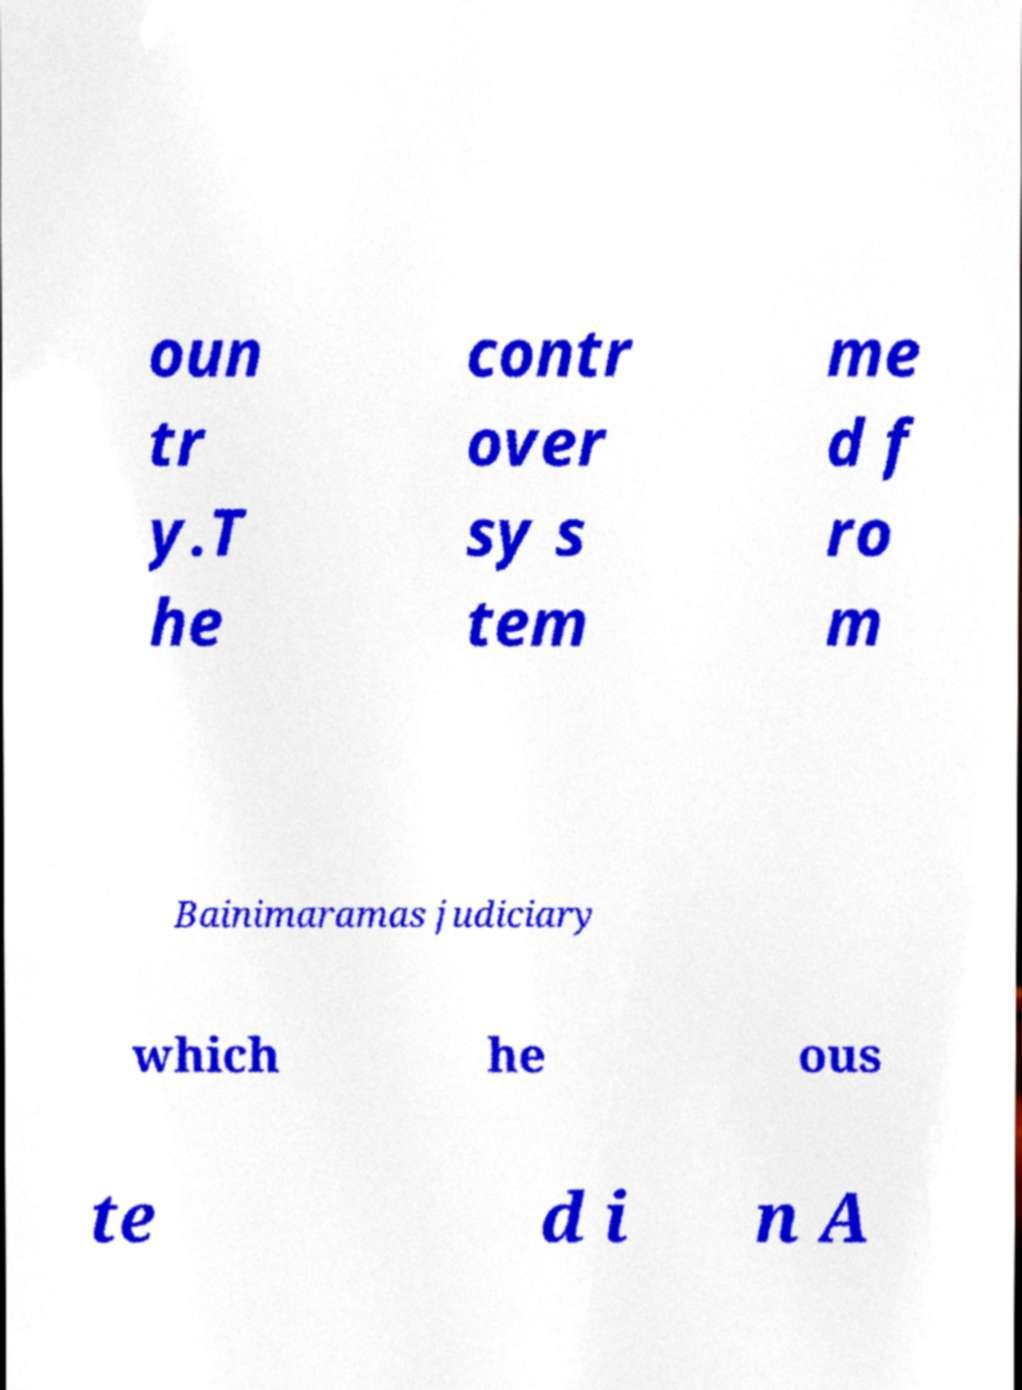There's text embedded in this image that I need extracted. Can you transcribe it verbatim? oun tr y.T he contr over sy s tem me d f ro m Bainimaramas judiciary which he ous te d i n A 